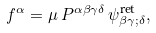Convert formula to latex. <formula><loc_0><loc_0><loc_500><loc_500>f ^ { \alpha } = { \mu } \, P ^ { { \alpha } { \beta } { \gamma } { \delta } } \, { \psi } ^ { \text {ret} } _ { { \beta } { \gamma } ; { \delta } } ,</formula> 